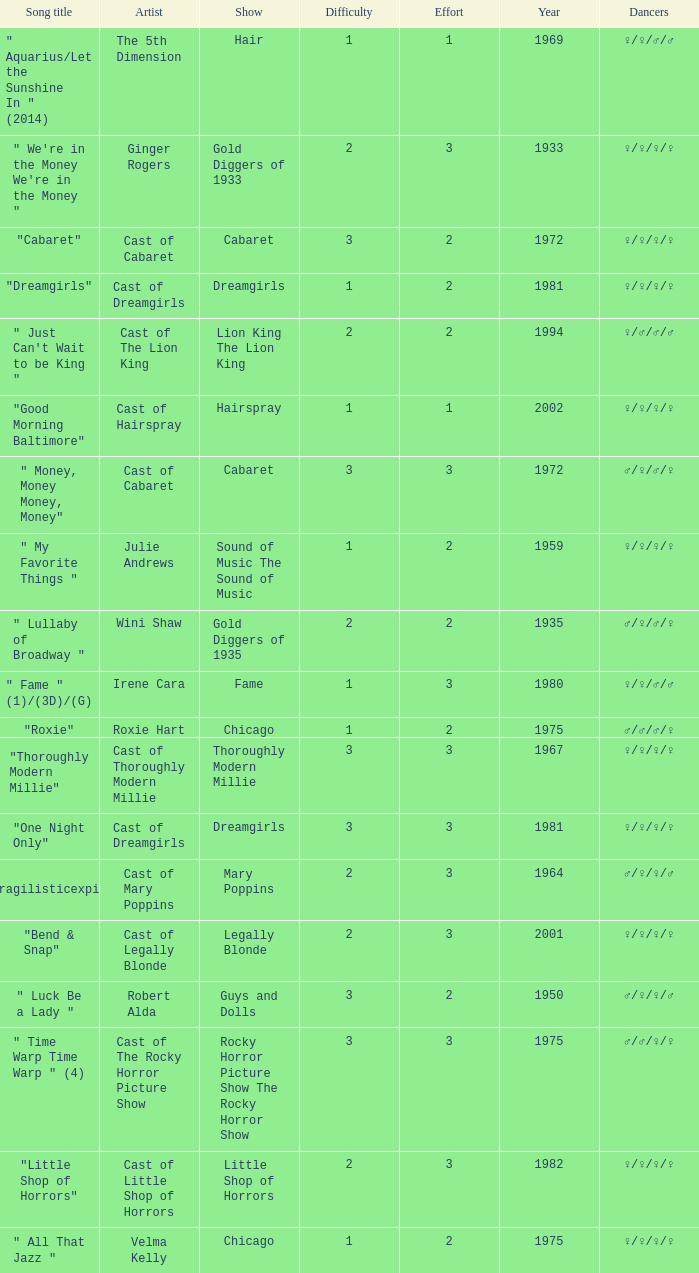What show featured the song "little shop of horrors"? Little Shop of Horrors. 